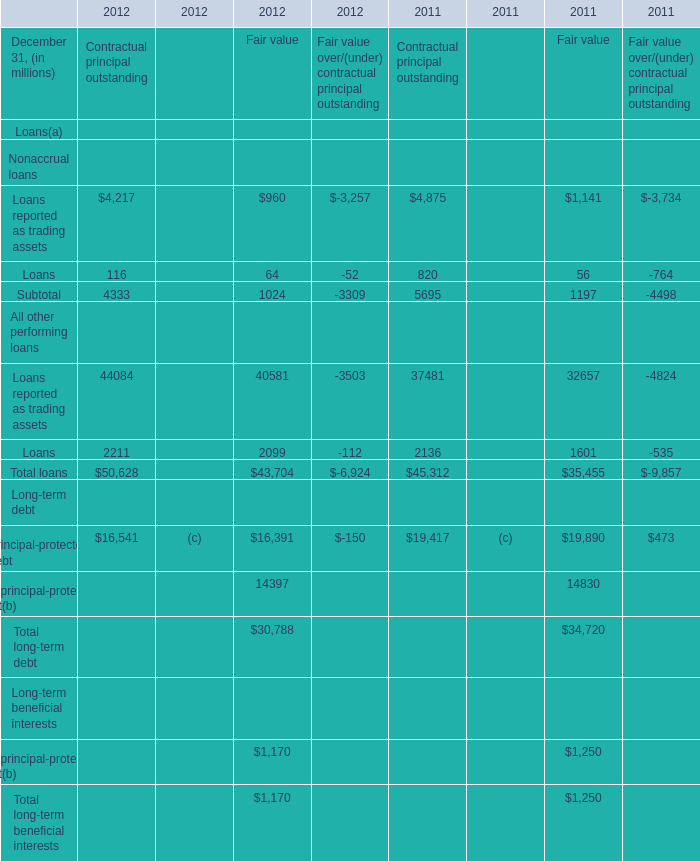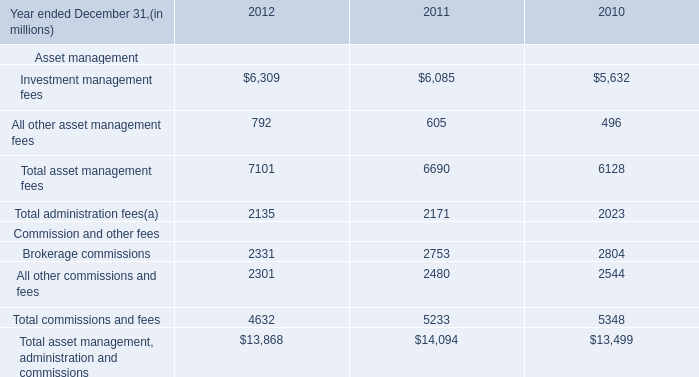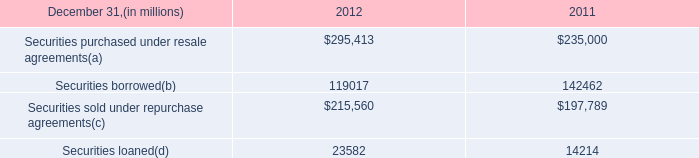What is the total amount of Investment management fees of 2011, and Loans All other performing loans of 2011 Contractual principal outstanding ? 
Computations: (6085.0 + 2136.0)
Answer: 8221.0. 